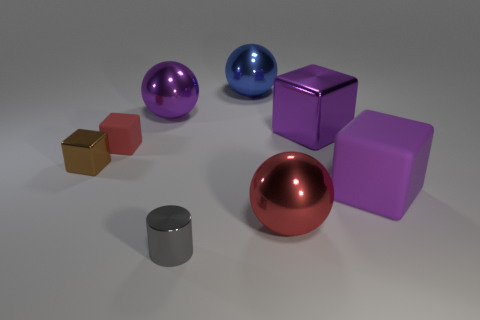Subtract all cyan blocks. Subtract all brown balls. How many blocks are left? 4 Add 1 rubber objects. How many objects exist? 9 Subtract all cylinders. How many objects are left? 7 Add 4 tiny gray blocks. How many tiny gray blocks exist? 4 Subtract 0 gray blocks. How many objects are left? 8 Subtract all tiny gray shiny blocks. Subtract all gray things. How many objects are left? 7 Add 5 small cylinders. How many small cylinders are left? 6 